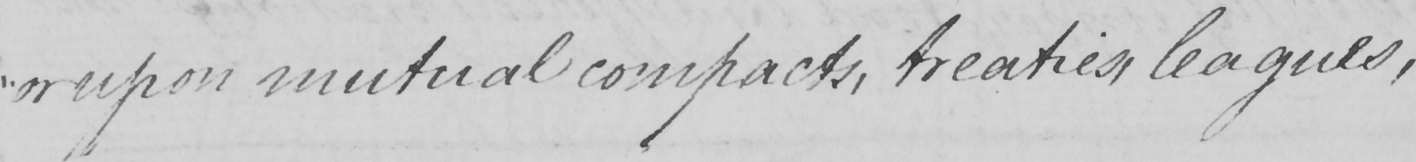What is written in this line of handwriting? " or upon mutual compacts , treaties , leagues , 